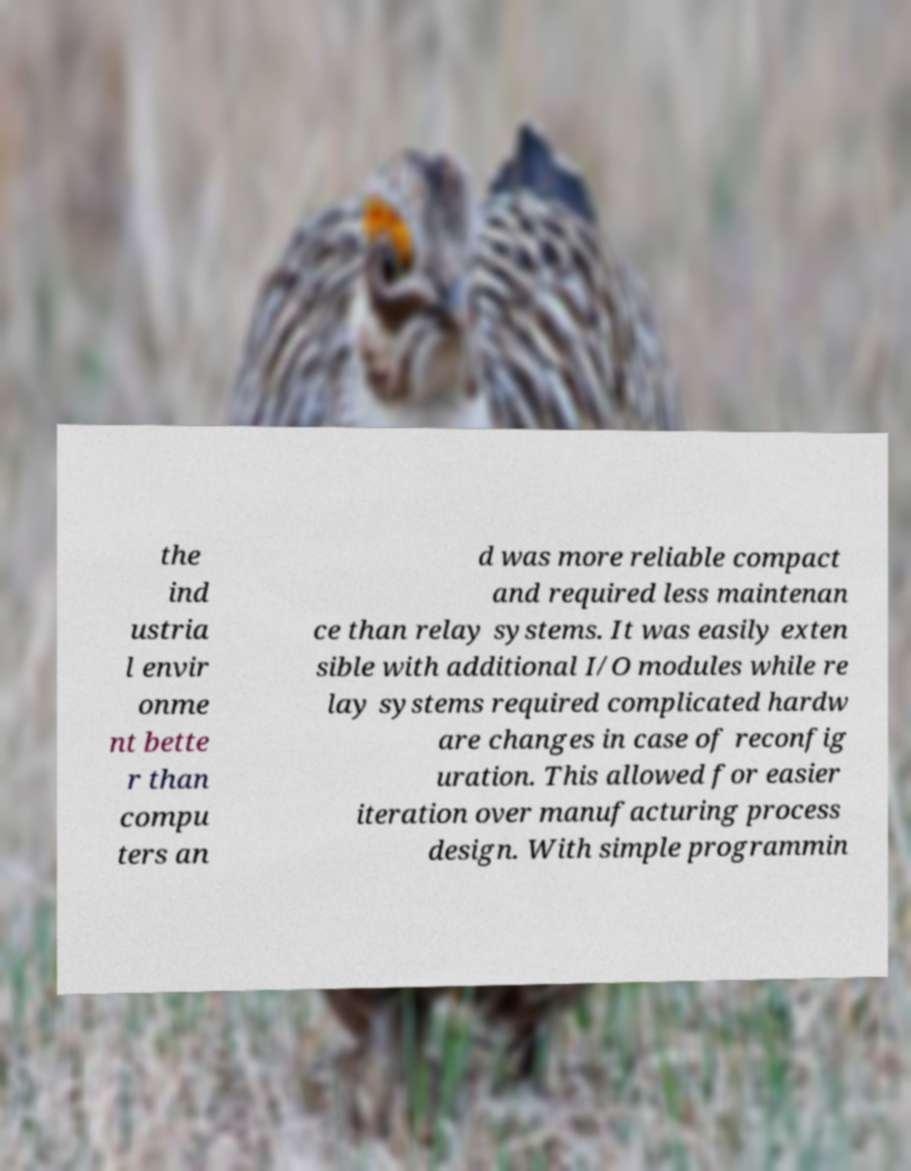I need the written content from this picture converted into text. Can you do that? the ind ustria l envir onme nt bette r than compu ters an d was more reliable compact and required less maintenan ce than relay systems. It was easily exten sible with additional I/O modules while re lay systems required complicated hardw are changes in case of reconfig uration. This allowed for easier iteration over manufacturing process design. With simple programmin 